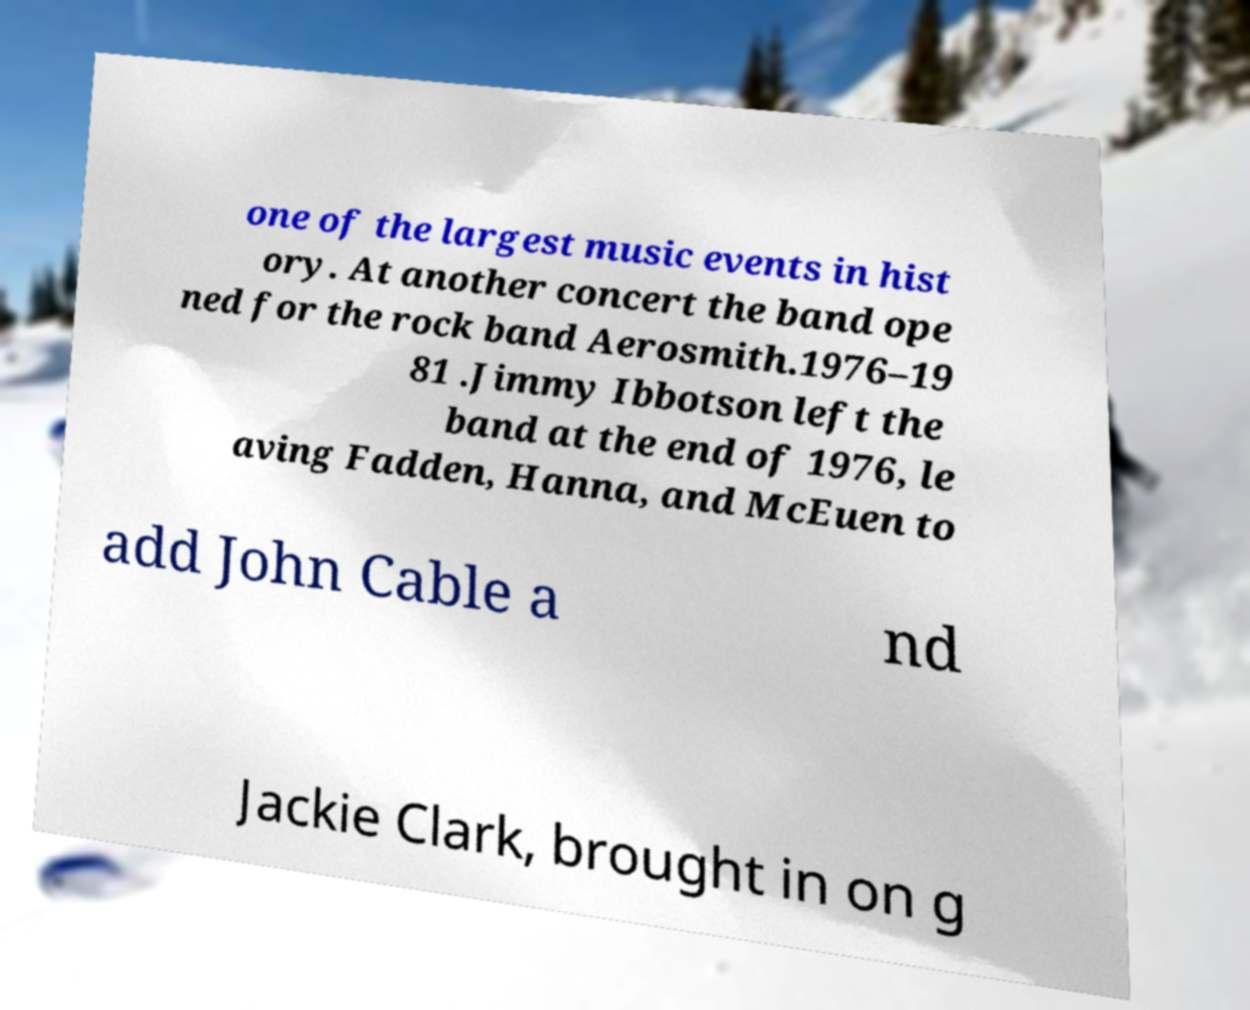Could you assist in decoding the text presented in this image and type it out clearly? one of the largest music events in hist ory. At another concert the band ope ned for the rock band Aerosmith.1976–19 81 .Jimmy Ibbotson left the band at the end of 1976, le aving Fadden, Hanna, and McEuen to add John Cable a nd Jackie Clark, brought in on g 